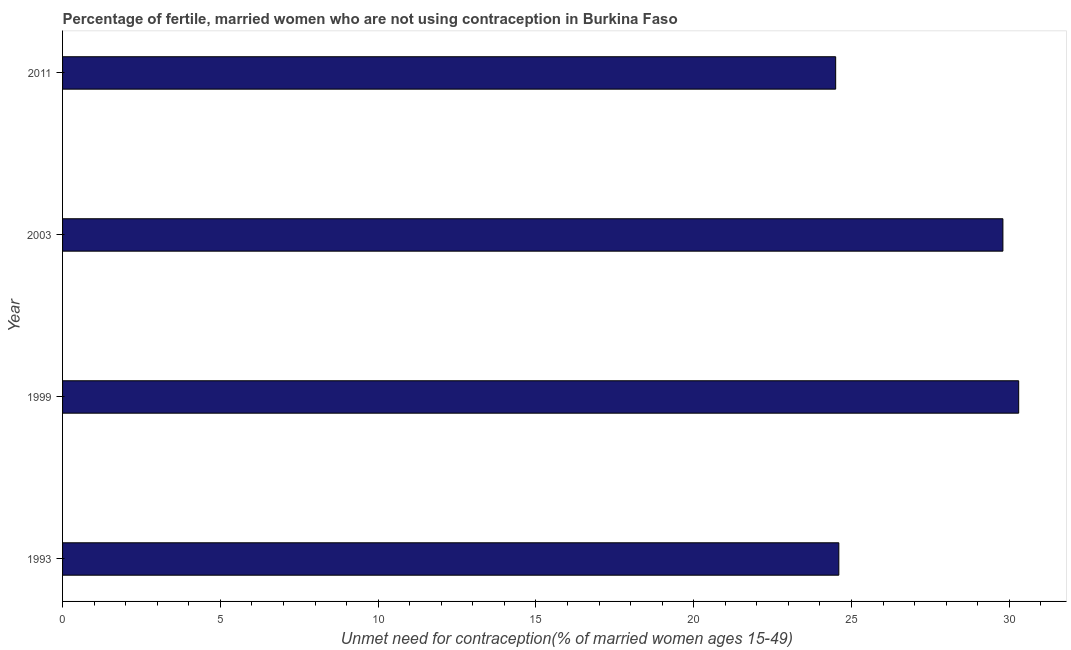Does the graph contain grids?
Provide a short and direct response. No. What is the title of the graph?
Keep it short and to the point. Percentage of fertile, married women who are not using contraception in Burkina Faso. What is the label or title of the X-axis?
Offer a very short reply.  Unmet need for contraception(% of married women ages 15-49). What is the label or title of the Y-axis?
Make the answer very short. Year. Across all years, what is the maximum number of married women who are not using contraception?
Provide a short and direct response. 30.3. In which year was the number of married women who are not using contraception minimum?
Make the answer very short. 2011. What is the sum of the number of married women who are not using contraception?
Keep it short and to the point. 109.2. What is the average number of married women who are not using contraception per year?
Ensure brevity in your answer.  27.3. What is the median number of married women who are not using contraception?
Offer a very short reply. 27.2. Do a majority of the years between 2003 and 1993 (inclusive) have number of married women who are not using contraception greater than 2 %?
Offer a terse response. Yes. What is the ratio of the number of married women who are not using contraception in 1993 to that in 2003?
Ensure brevity in your answer.  0.83. Is the number of married women who are not using contraception in 1993 less than that in 2003?
Keep it short and to the point. Yes. Is the sum of the number of married women who are not using contraception in 1993 and 1999 greater than the maximum number of married women who are not using contraception across all years?
Keep it short and to the point. Yes. What is the difference between the highest and the lowest number of married women who are not using contraception?
Offer a terse response. 5.8. In how many years, is the number of married women who are not using contraception greater than the average number of married women who are not using contraception taken over all years?
Ensure brevity in your answer.  2. How many bars are there?
Your response must be concise. 4. Are all the bars in the graph horizontal?
Provide a short and direct response. Yes. How many years are there in the graph?
Keep it short and to the point. 4. What is the difference between two consecutive major ticks on the X-axis?
Keep it short and to the point. 5. What is the  Unmet need for contraception(% of married women ages 15-49) of 1993?
Provide a short and direct response. 24.6. What is the  Unmet need for contraception(% of married women ages 15-49) in 1999?
Give a very brief answer. 30.3. What is the  Unmet need for contraception(% of married women ages 15-49) of 2003?
Ensure brevity in your answer.  29.8. What is the difference between the  Unmet need for contraception(% of married women ages 15-49) in 1993 and 1999?
Offer a terse response. -5.7. What is the ratio of the  Unmet need for contraception(% of married women ages 15-49) in 1993 to that in 1999?
Offer a terse response. 0.81. What is the ratio of the  Unmet need for contraception(% of married women ages 15-49) in 1993 to that in 2003?
Keep it short and to the point. 0.83. What is the ratio of the  Unmet need for contraception(% of married women ages 15-49) in 1993 to that in 2011?
Provide a short and direct response. 1. What is the ratio of the  Unmet need for contraception(% of married women ages 15-49) in 1999 to that in 2011?
Offer a very short reply. 1.24. What is the ratio of the  Unmet need for contraception(% of married women ages 15-49) in 2003 to that in 2011?
Make the answer very short. 1.22. 